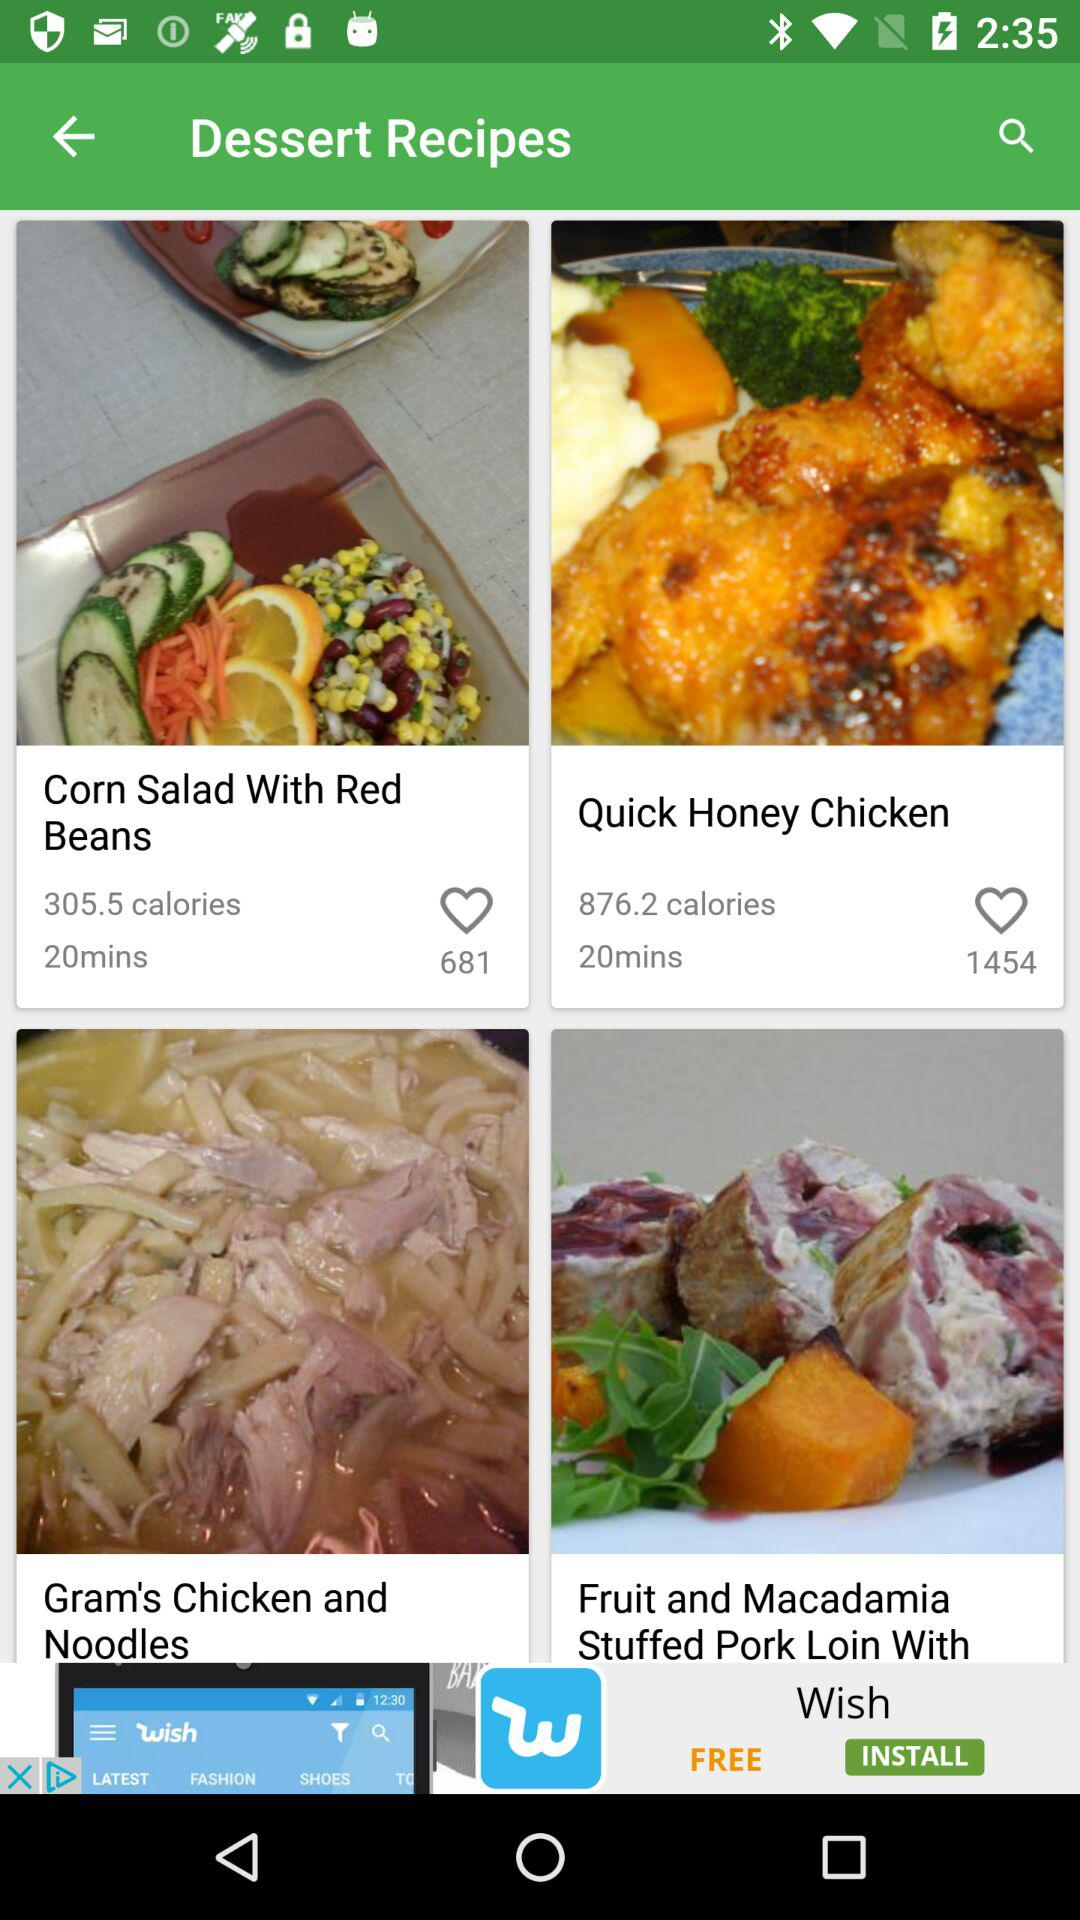How much time is required to make "Corn Salad With Red Beans"? The time required to make "Corn Salad With Red Beans" is 20 minutes. 